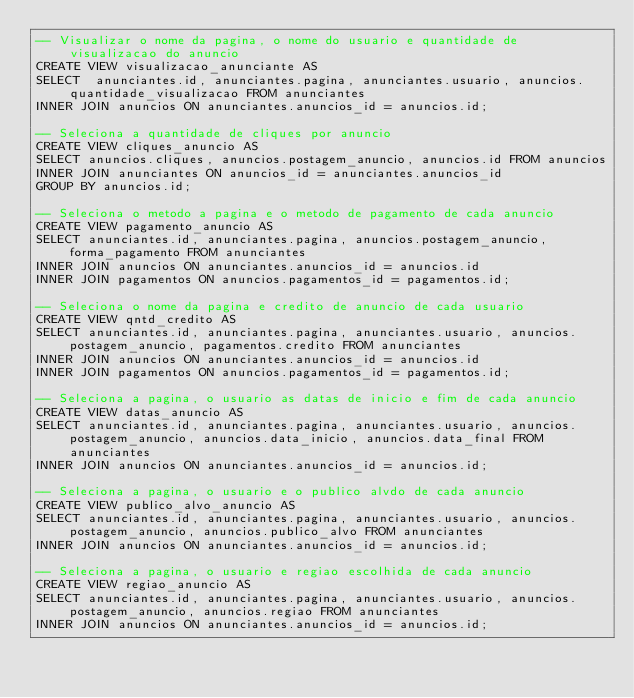Convert code to text. <code><loc_0><loc_0><loc_500><loc_500><_SQL_>-- Visualizar o nome da pagina, o nome do usuario e quantidade de visualizacao do anuncio
CREATE VIEW visualizacao_anunciante AS 
SELECT  anunciantes.id, anunciantes.pagina, anunciantes.usuario, anuncios.quantidade_visualizacao FROM anunciantes
INNER JOIN anuncios ON anunciantes.anuncios_id = anuncios.id;

-- Seleciona a quantidade de cliques por anuncio
CREATE VIEW cliques_anuncio AS 
SELECT anuncios.cliques, anuncios.postagem_anuncio, anuncios.id FROM anuncios
INNER JOIN anunciantes ON anuncios_id = anunciantes.anuncios_id
GROUP BY anuncios.id;

-- Seleciona o metodo a pagina e o metodo de pagamento de cada anuncio
CREATE VIEW pagamento_anuncio AS
SELECT anunciantes.id, anunciantes.pagina, anuncios.postagem_anuncio, forma_pagamento FROM anunciantes
INNER JOIN anuncios ON anunciantes.anuncios_id = anuncios.id 
INNER JOIN pagamentos ON anuncios.pagamentos_id = pagamentos.id;

-- Seleciona o nome da pagina e credito de anuncio de cada usuario
CREATE VIEW qntd_credito AS
SELECT anunciantes.id, anunciantes.pagina, anunciantes.usuario, anuncios.postagem_anuncio, pagamentos.credito FROM anunciantes
INNER JOIN anuncios ON anunciantes.anuncios_id = anuncios.id
INNER JOIN pagamentos ON anuncios.pagamentos_id = pagamentos.id;

-- Seleciona a pagina, o usuario as datas de inicio e fim de cada anuncio
CREATE VIEW datas_anuncio AS
SELECT anunciantes.id, anunciantes.pagina, anunciantes.usuario, anuncios.postagem_anuncio, anuncios.data_inicio, anuncios.data_final FROM anunciantes
INNER JOIN anuncios ON anunciantes.anuncios_id = anuncios.id;

-- Seleciona a pagina, o usuario e o publico alvdo de cada anuncio
CREATE VIEW publico_alvo_anuncio AS
SELECT anunciantes.id, anunciantes.pagina, anunciantes.usuario, anuncios.postagem_anuncio, anuncios.publico_alvo FROM anunciantes
INNER JOIN anuncios ON anunciantes.anuncios_id = anuncios.id;

-- Seleciona a pagina, o usuario e regiao escolhida de cada anuncio
CREATE VIEW regiao_anuncio AS
SELECT anunciantes.id, anunciantes.pagina, anunciantes.usuario, anuncios.postagem_anuncio, anuncios.regiao FROM anunciantes
INNER JOIN anuncios ON anunciantes.anuncios_id = anuncios.id;</code> 